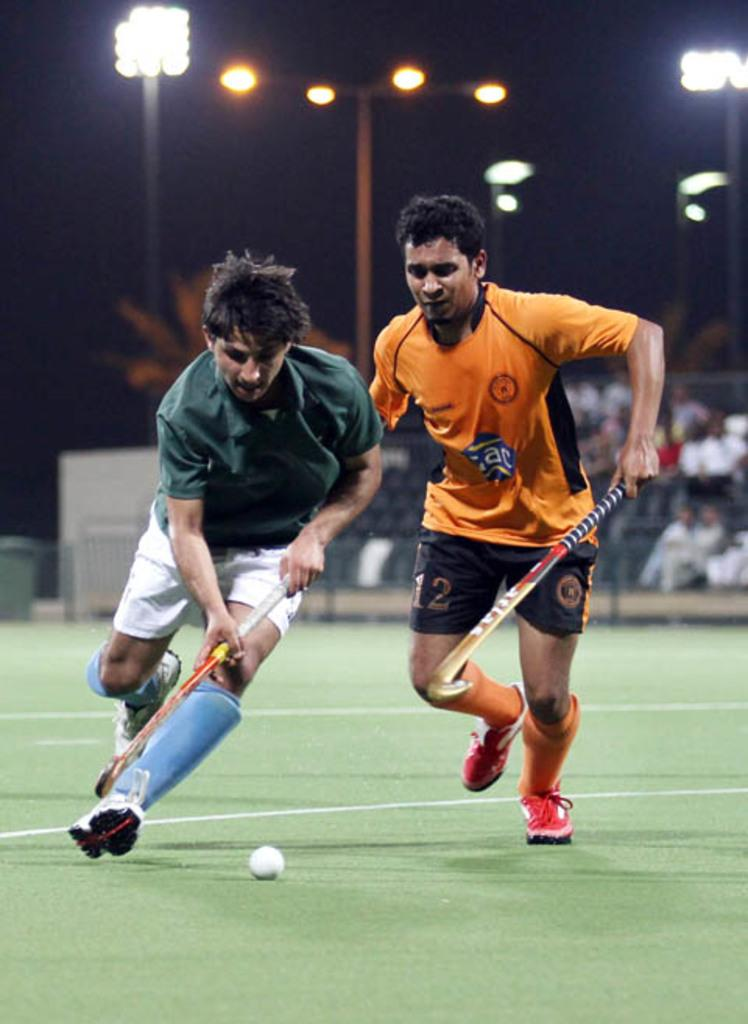<image>
Create a compact narrative representing the image presented. number 12 in orange and black chasing player in green and white with the ball 